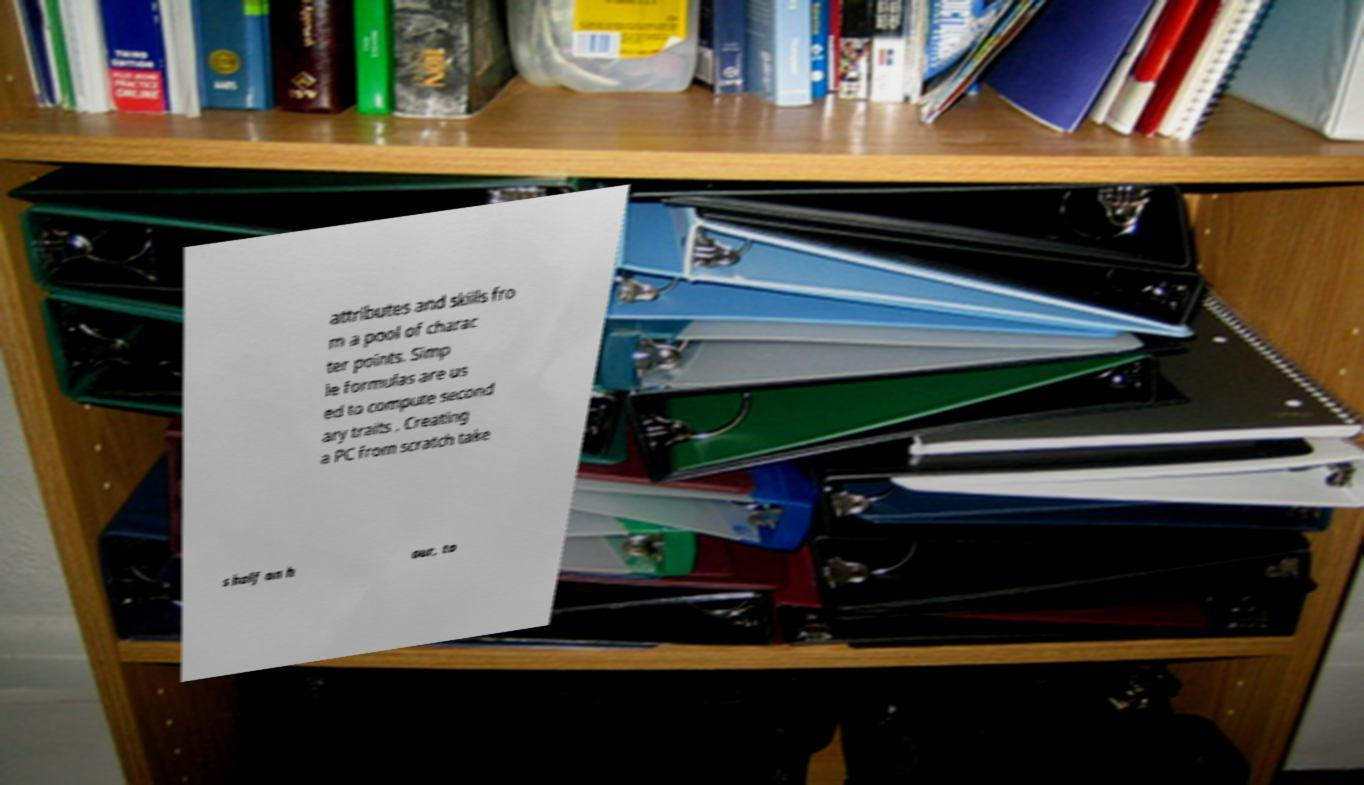Can you accurately transcribe the text from the provided image for me? attributes and skills fro m a pool of charac ter points. Simp le formulas are us ed to compute second ary traits . Creating a PC from scratch take s half an h our, to 